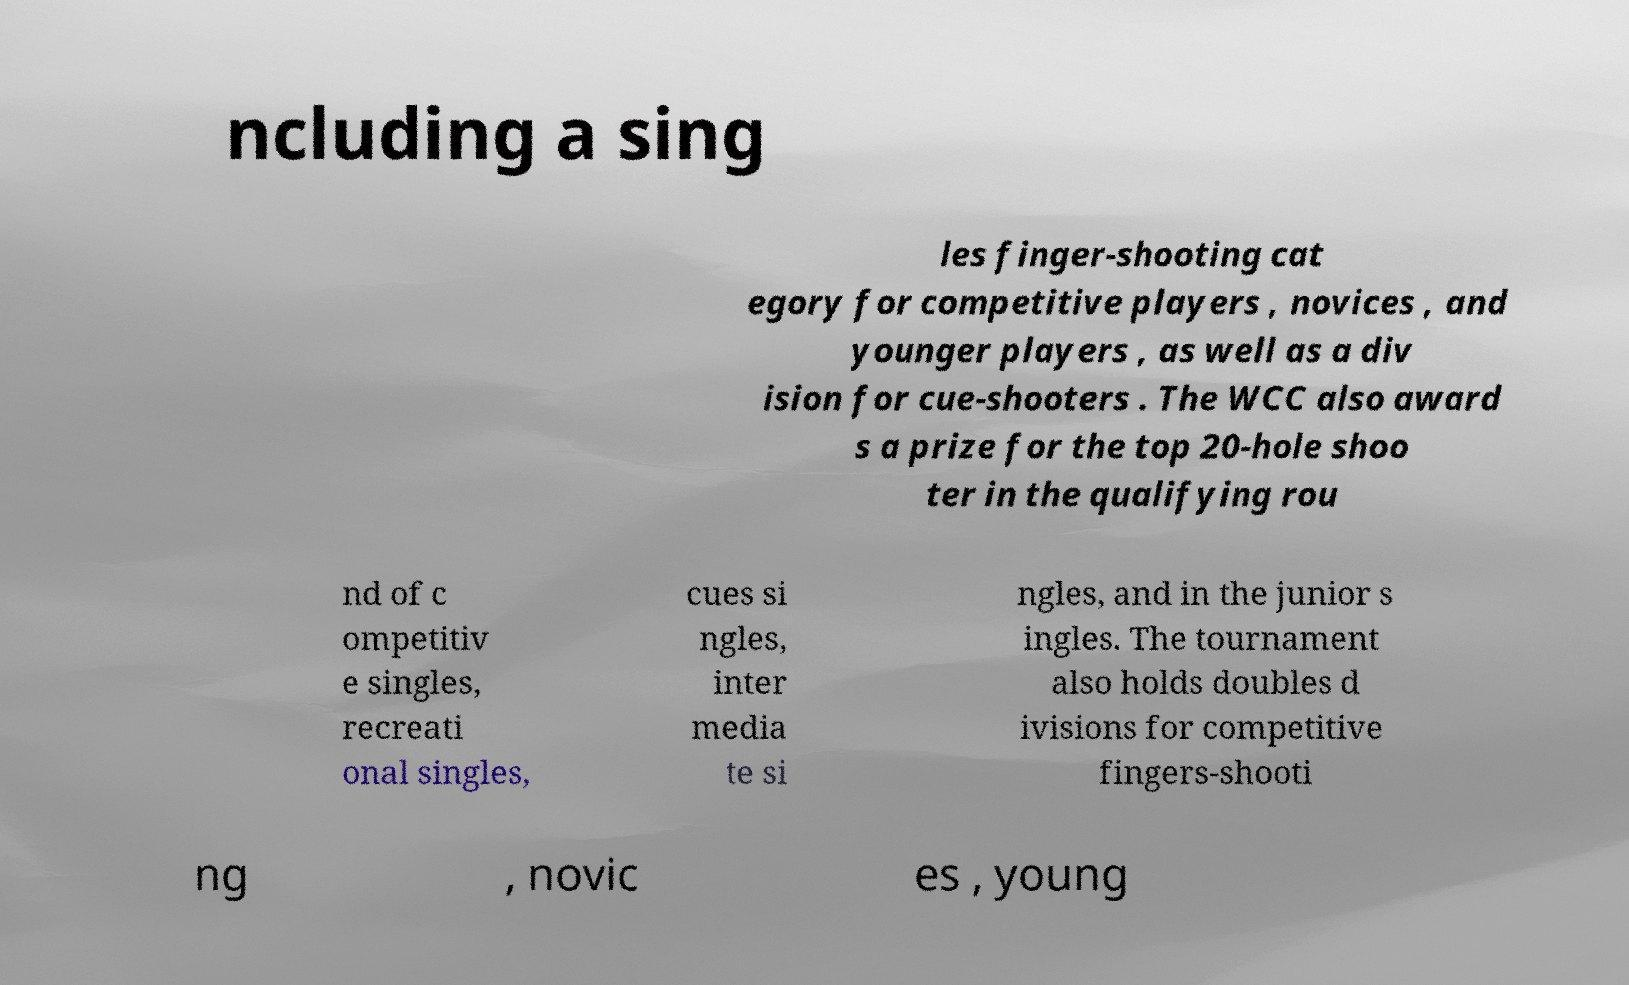Please identify and transcribe the text found in this image. ncluding a sing les finger-shooting cat egory for competitive players , novices , and younger players , as well as a div ision for cue-shooters . The WCC also award s a prize for the top 20-hole shoo ter in the qualifying rou nd of c ompetitiv e singles, recreati onal singles, cues si ngles, inter media te si ngles, and in the junior s ingles. The tournament also holds doubles d ivisions for competitive fingers-shooti ng , novic es , young 